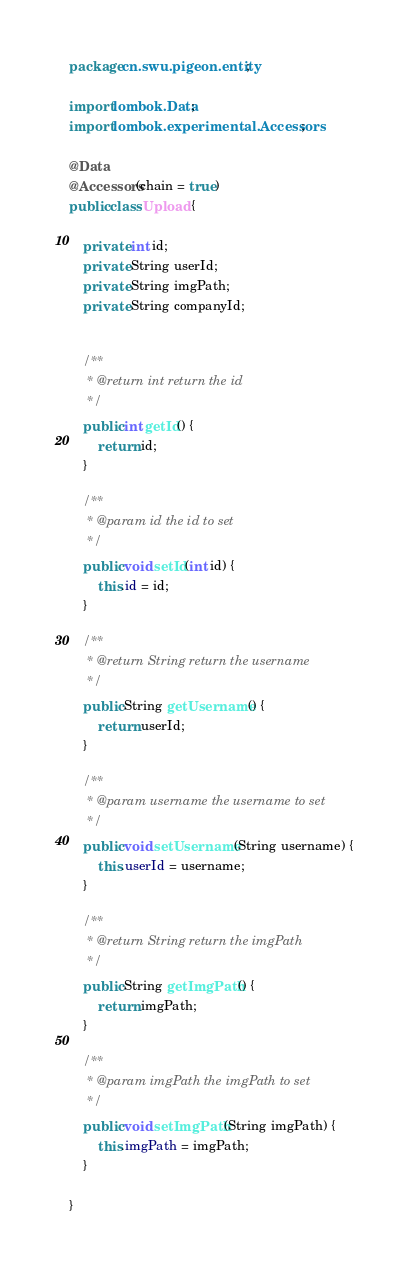<code> <loc_0><loc_0><loc_500><loc_500><_Java_>package cn.swu.pigeon.entity;

import lombok.Data;
import lombok.experimental.Accessors;

@Data
@Accessors(chain = true)
public class Upload {

    private int id;
    private String userId;
    private String imgPath;
    private String companyId;


    /**
     * @return int return the id
     */
    public int getId() {
        return id;
    }

    /**
     * @param id the id to set
     */
    public void setId(int id) {
        this.id = id;
    }

    /**
     * @return String return the username
     */
    public String getUsername() {
        return userId;
    }

    /**
     * @param username the username to set
     */
    public void setUsername(String username) {
        this.userId = username;
    }

    /**
     * @return String return the imgPath
     */
    public String getImgPath() {
        return imgPath;
    }

    /**
     * @param imgPath the imgPath to set
     */
    public void setImgPath(String imgPath) {
        this.imgPath = imgPath;
    }

}
</code> 